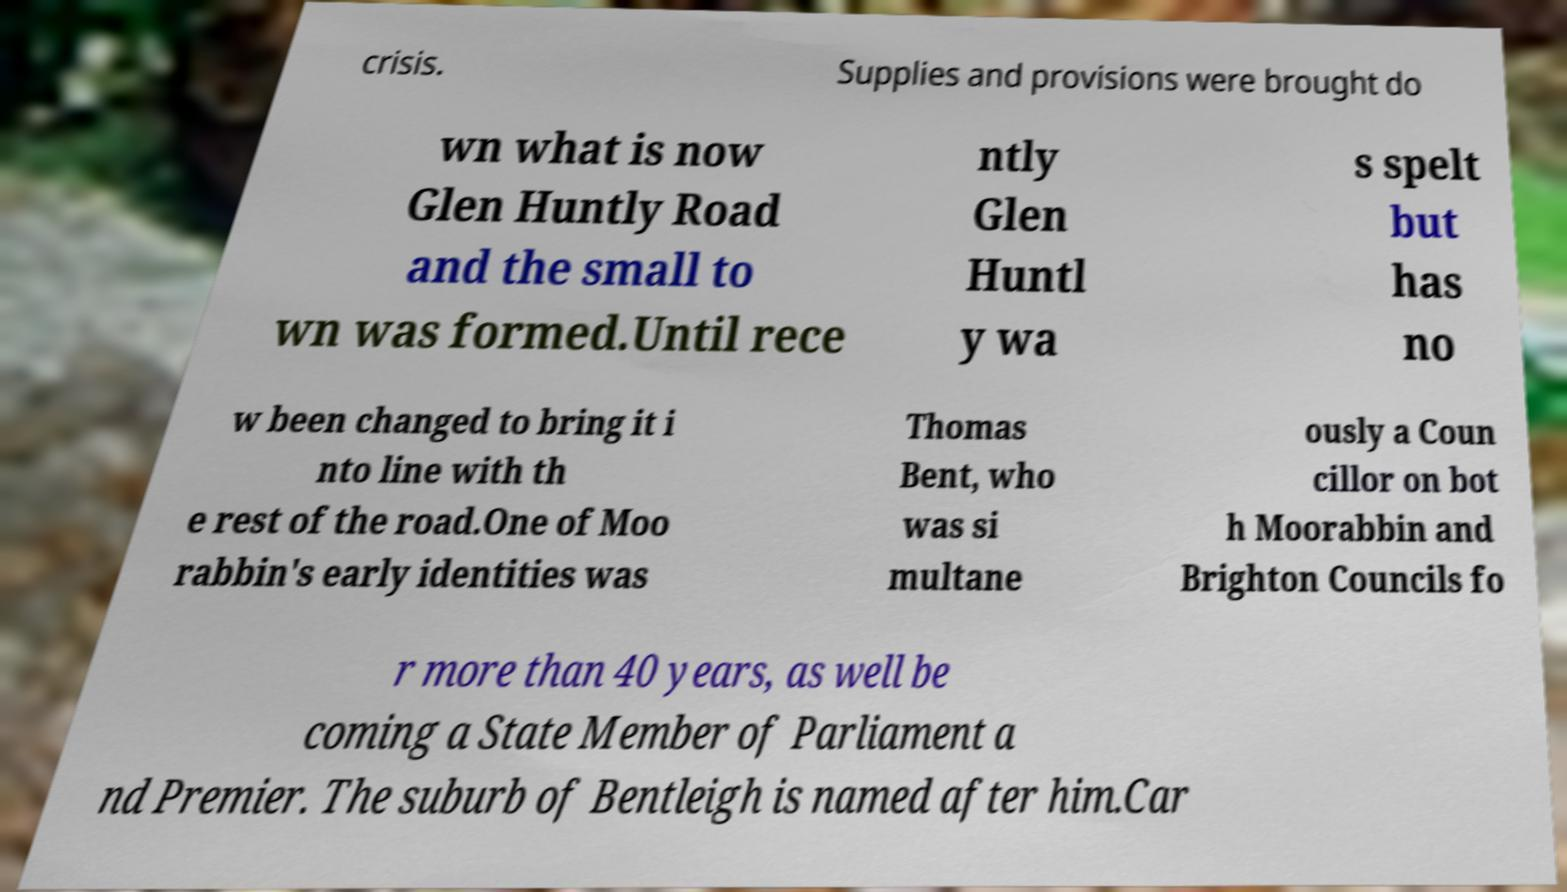For documentation purposes, I need the text within this image transcribed. Could you provide that? crisis. Supplies and provisions were brought do wn what is now Glen Huntly Road and the small to wn was formed.Until rece ntly Glen Huntl y wa s spelt but has no w been changed to bring it i nto line with th e rest of the road.One of Moo rabbin's early identities was Thomas Bent, who was si multane ously a Coun cillor on bot h Moorabbin and Brighton Councils fo r more than 40 years, as well be coming a State Member of Parliament a nd Premier. The suburb of Bentleigh is named after him.Car 